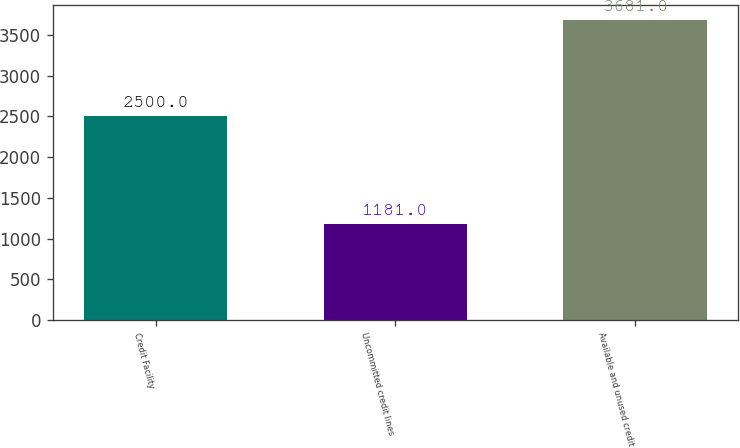<chart> <loc_0><loc_0><loc_500><loc_500><bar_chart><fcel>Credit Facility<fcel>Uncommitted credit lines<fcel>Available and unused credit<nl><fcel>2500<fcel>1181<fcel>3681<nl></chart> 